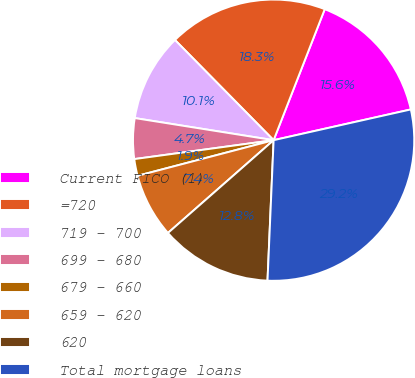Convert chart to OTSL. <chart><loc_0><loc_0><loc_500><loc_500><pie_chart><fcel>Current FICO (1)<fcel>=720<fcel>719 - 700<fcel>699 - 680<fcel>679 - 660<fcel>659 - 620<fcel>620<fcel>Total mortgage loans<nl><fcel>15.57%<fcel>18.3%<fcel>10.11%<fcel>4.66%<fcel>1.93%<fcel>7.39%<fcel>12.84%<fcel>29.2%<nl></chart> 